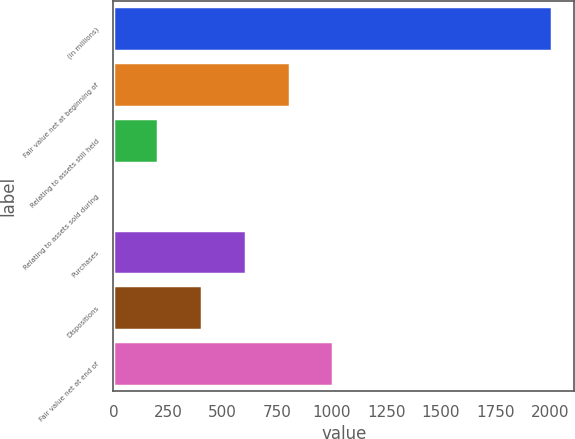<chart> <loc_0><loc_0><loc_500><loc_500><bar_chart><fcel>(in millions)<fcel>Fair value net at beginning of<fcel>Relating to assets still held<fcel>Relating to assets sold during<fcel>Purchases<fcel>Dispositions<fcel>Fair value net at end of<nl><fcel>2012<fcel>807.8<fcel>205.7<fcel>5<fcel>607.1<fcel>406.4<fcel>1008.5<nl></chart> 